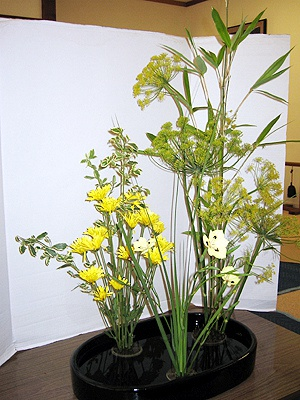Describe the objects in this image and their specific colors. I can see potted plant in olive, lightgray, black, and darkgreen tones, vase in olive, black, darkgreen, and gray tones, potted plant in olive, darkgreen, black, and lavender tones, and vase in olive, black, darkgreen, and gray tones in this image. 